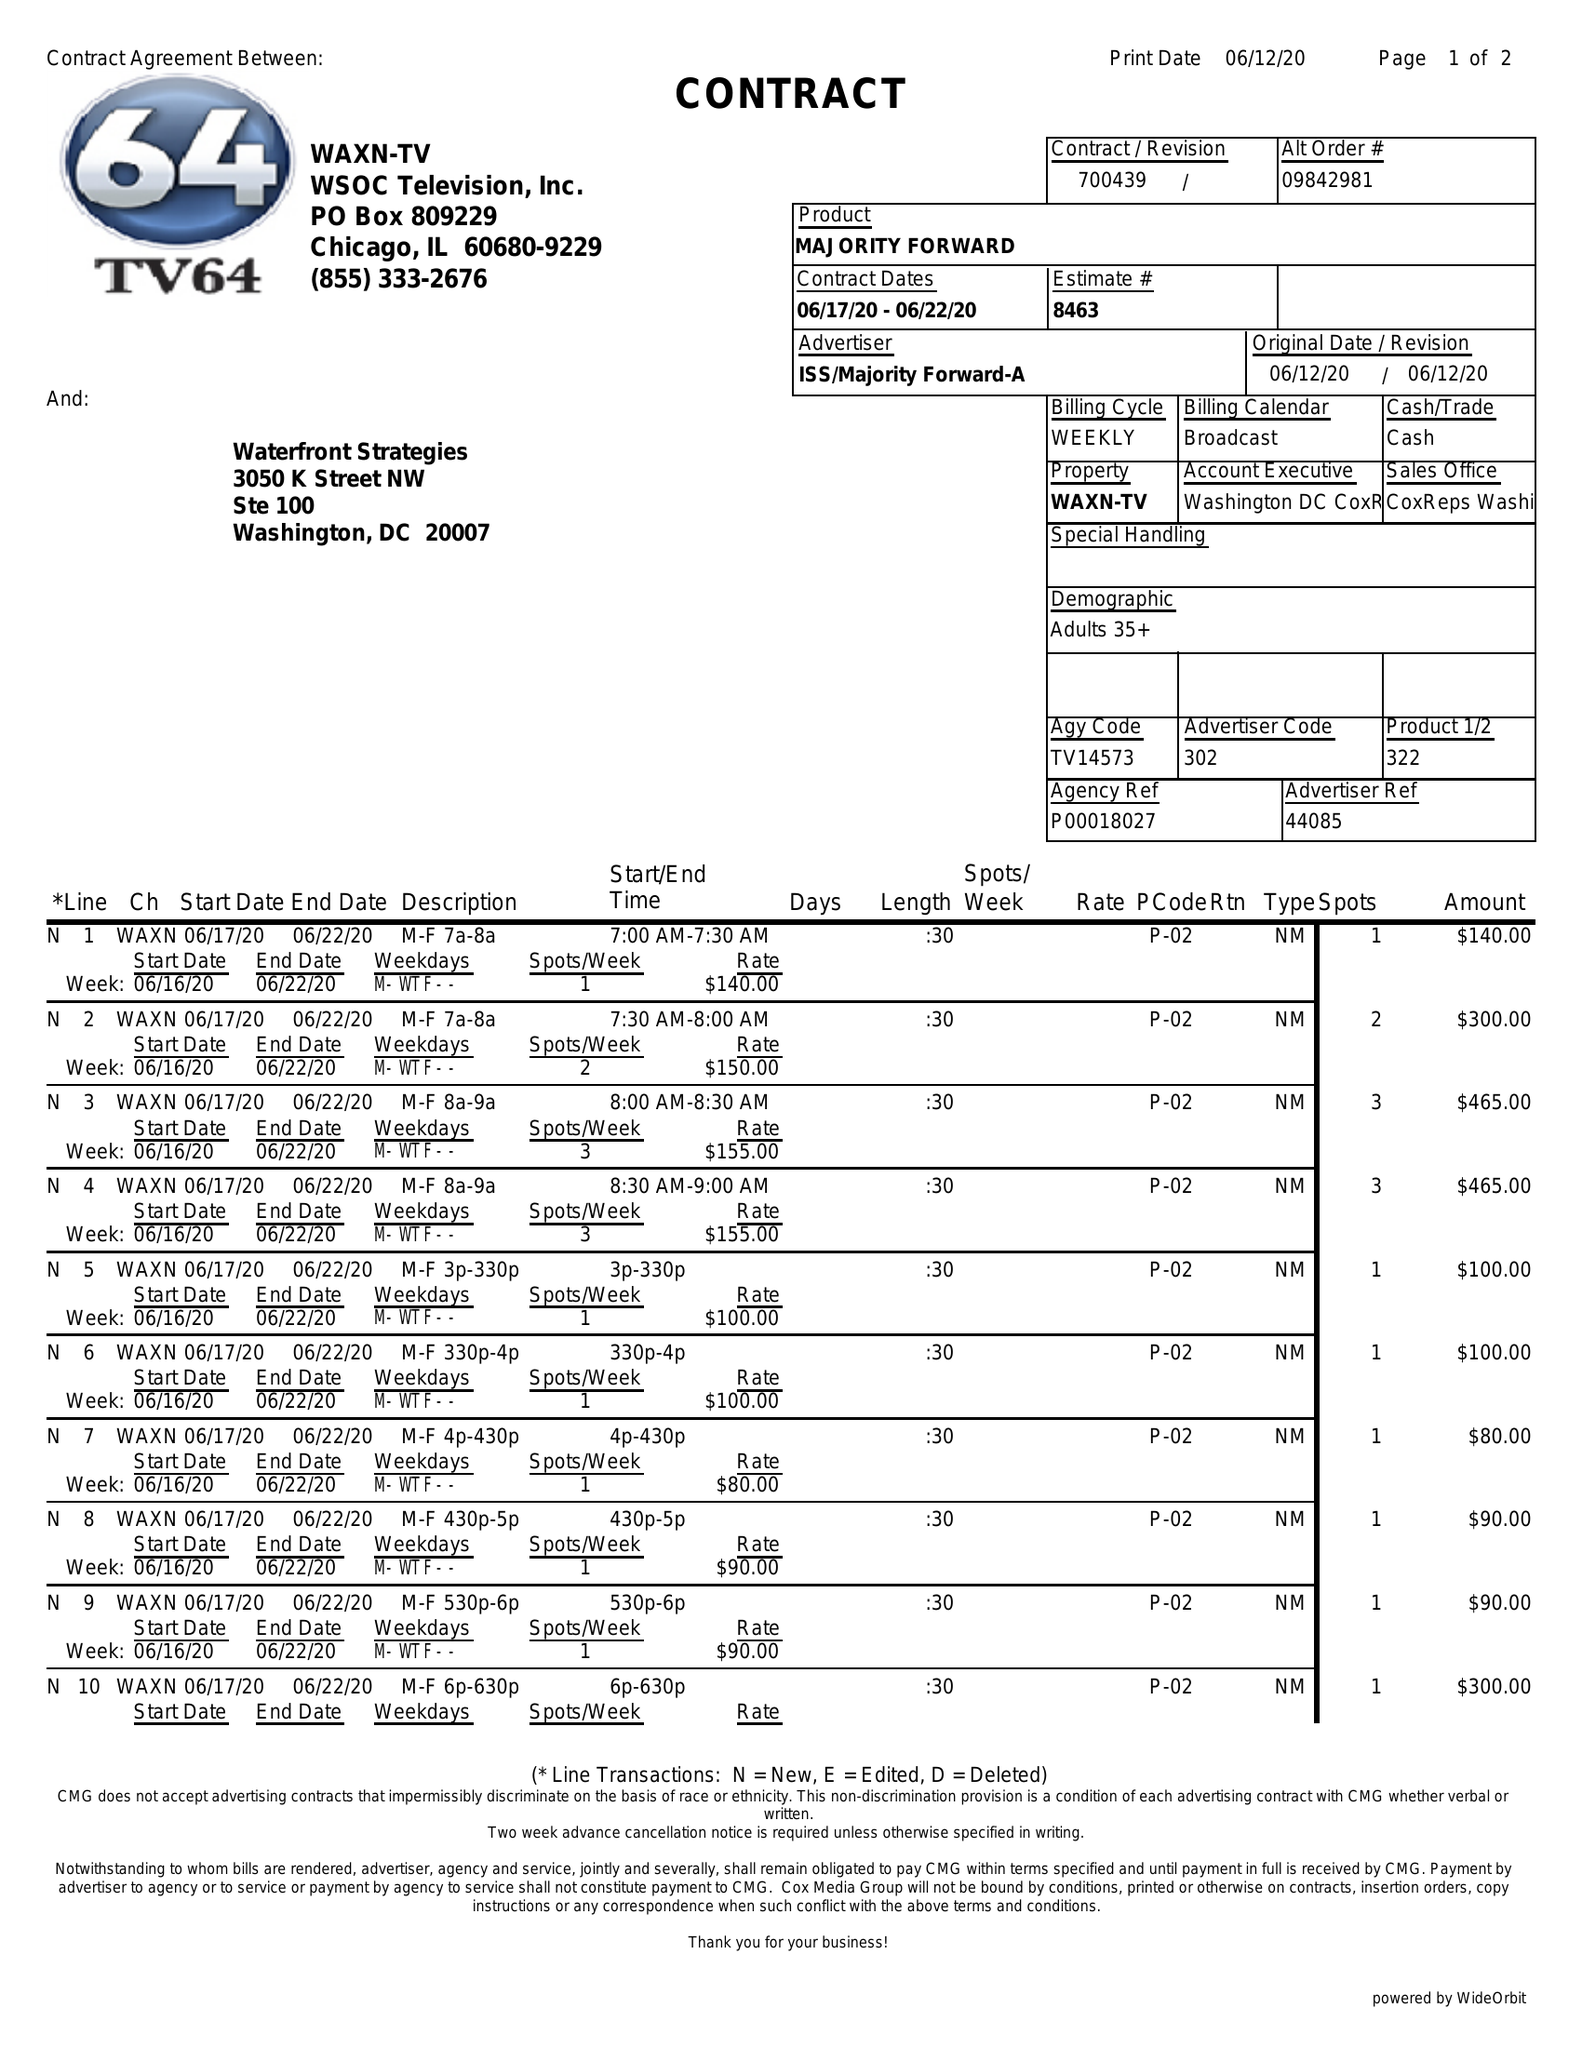What is the value for the contract_num?
Answer the question using a single word or phrase. 700439 